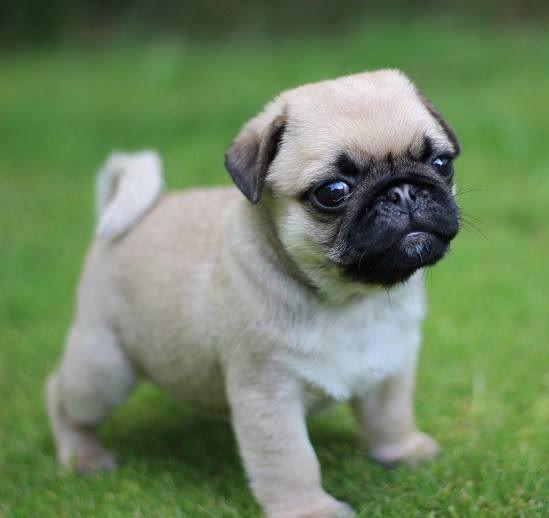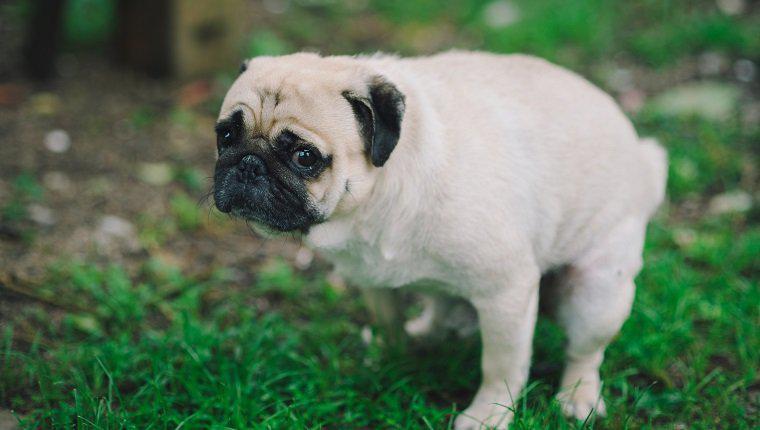The first image is the image on the left, the second image is the image on the right. Analyze the images presented: Is the assertion "At least one dog has a visible collar." valid? Answer yes or no. No. 